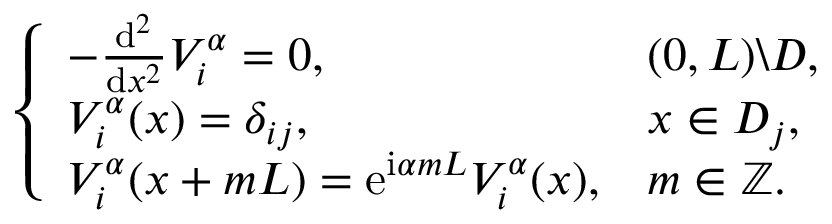<formula> <loc_0><loc_0><loc_500><loc_500>\left \{ \begin{array} { l l } { - \frac { d ^ { 2 } } { d x ^ { 2 } } V _ { i } ^ { \alpha } = 0 , } & { ( 0 , L ) \ D , } \\ { V _ { i } ^ { \alpha } ( x ) = \delta _ { i j } , } & { x \in D _ { j } , } \\ { V _ { i } ^ { \alpha } ( x + m L ) = e ^ { i \alpha m L } V _ { i } ^ { \alpha } ( x ) , } & { m \in \mathbb { Z } . } \end{array}</formula> 